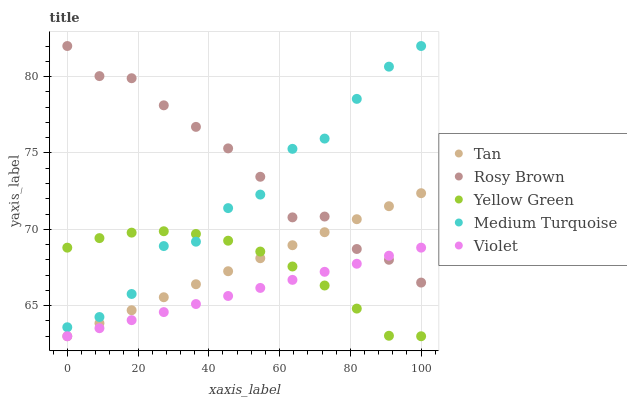Does Violet have the minimum area under the curve?
Answer yes or no. Yes. Does Rosy Brown have the maximum area under the curve?
Answer yes or no. Yes. Does Yellow Green have the minimum area under the curve?
Answer yes or no. No. Does Yellow Green have the maximum area under the curve?
Answer yes or no. No. Is Tan the smoothest?
Answer yes or no. Yes. Is Medium Turquoise the roughest?
Answer yes or no. Yes. Is Rosy Brown the smoothest?
Answer yes or no. No. Is Rosy Brown the roughest?
Answer yes or no. No. Does Tan have the lowest value?
Answer yes or no. Yes. Does Rosy Brown have the lowest value?
Answer yes or no. No. Does Medium Turquoise have the highest value?
Answer yes or no. Yes. Does Yellow Green have the highest value?
Answer yes or no. No. Is Violet less than Medium Turquoise?
Answer yes or no. Yes. Is Medium Turquoise greater than Violet?
Answer yes or no. Yes. Does Yellow Green intersect Medium Turquoise?
Answer yes or no. Yes. Is Yellow Green less than Medium Turquoise?
Answer yes or no. No. Is Yellow Green greater than Medium Turquoise?
Answer yes or no. No. Does Violet intersect Medium Turquoise?
Answer yes or no. No. 